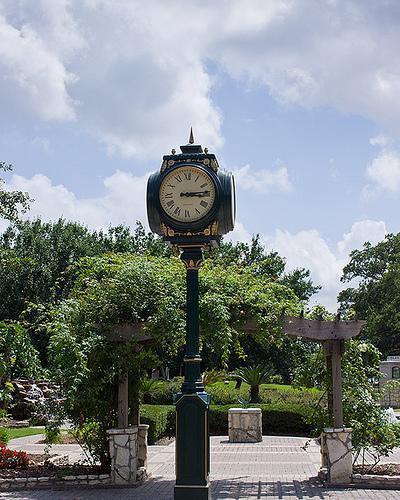How many clocks are in the picture?
Give a very brief answer. 1. 